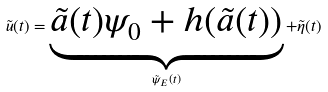Convert formula to latex. <formula><loc_0><loc_0><loc_500><loc_500>\tilde { u } ( t ) = \underbrace { \tilde { a } ( t ) \psi _ { 0 } + h ( \tilde { a } ( t ) ) } _ { \tilde { \psi } _ { E } ( t ) } + \tilde { \eta } ( t )</formula> 